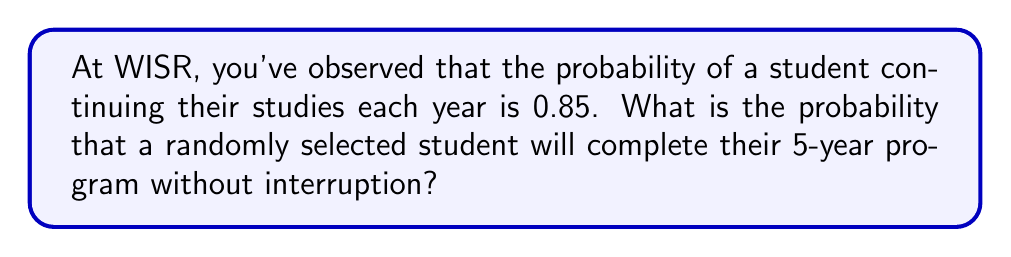Solve this math problem. To solve this problem, we need to follow these steps:

1) The probability of a student continuing each year is 0.85. This means the student needs to continue for 5 consecutive years.

2) Since the events of continuing each year are independent, we can use the multiplication rule of probability.

3) The probability of completing all 5 years is the product of the probabilities for each year:

   $$P(\text{completing 5 years}) = 0.85 \times 0.85 \times 0.85 \times 0.85 \times 0.85$$

4) This can be written as:

   $$P(\text{completing 5 years}) = (0.85)^5$$

5) Now, let's calculate this:

   $$(0.85)^5 = 0.4437$$

6) Rounding to three decimal places:

   $$P(\text{completing 5 years}) \approx 0.444$$

Therefore, the probability that a randomly selected student will complete their 5-year program without interruption is approximately 0.444 or 44.4%.
Answer: 0.444 